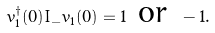Convert formula to latex. <formula><loc_0><loc_0><loc_500><loc_500>v _ { 1 } ^ { \dag } ( 0 ) I _ { - } v _ { 1 } ( 0 ) = 1 \text { or } - 1 .</formula> 